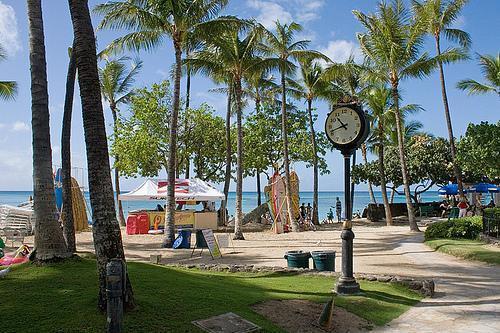These people are most likely on what type of event?
Choose the right answer from the provided options to respond to the question.
Options: Vacation, demolition, mob hit, diplomatic meeting. Vacation. 